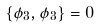Convert formula to latex. <formula><loc_0><loc_0><loc_500><loc_500>\{ \phi _ { 3 } , \phi _ { 3 } \} = 0</formula> 